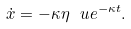<formula> <loc_0><loc_0><loc_500><loc_500>\dot { x } = - \kappa \eta \ u e ^ { - \kappa t } .</formula> 